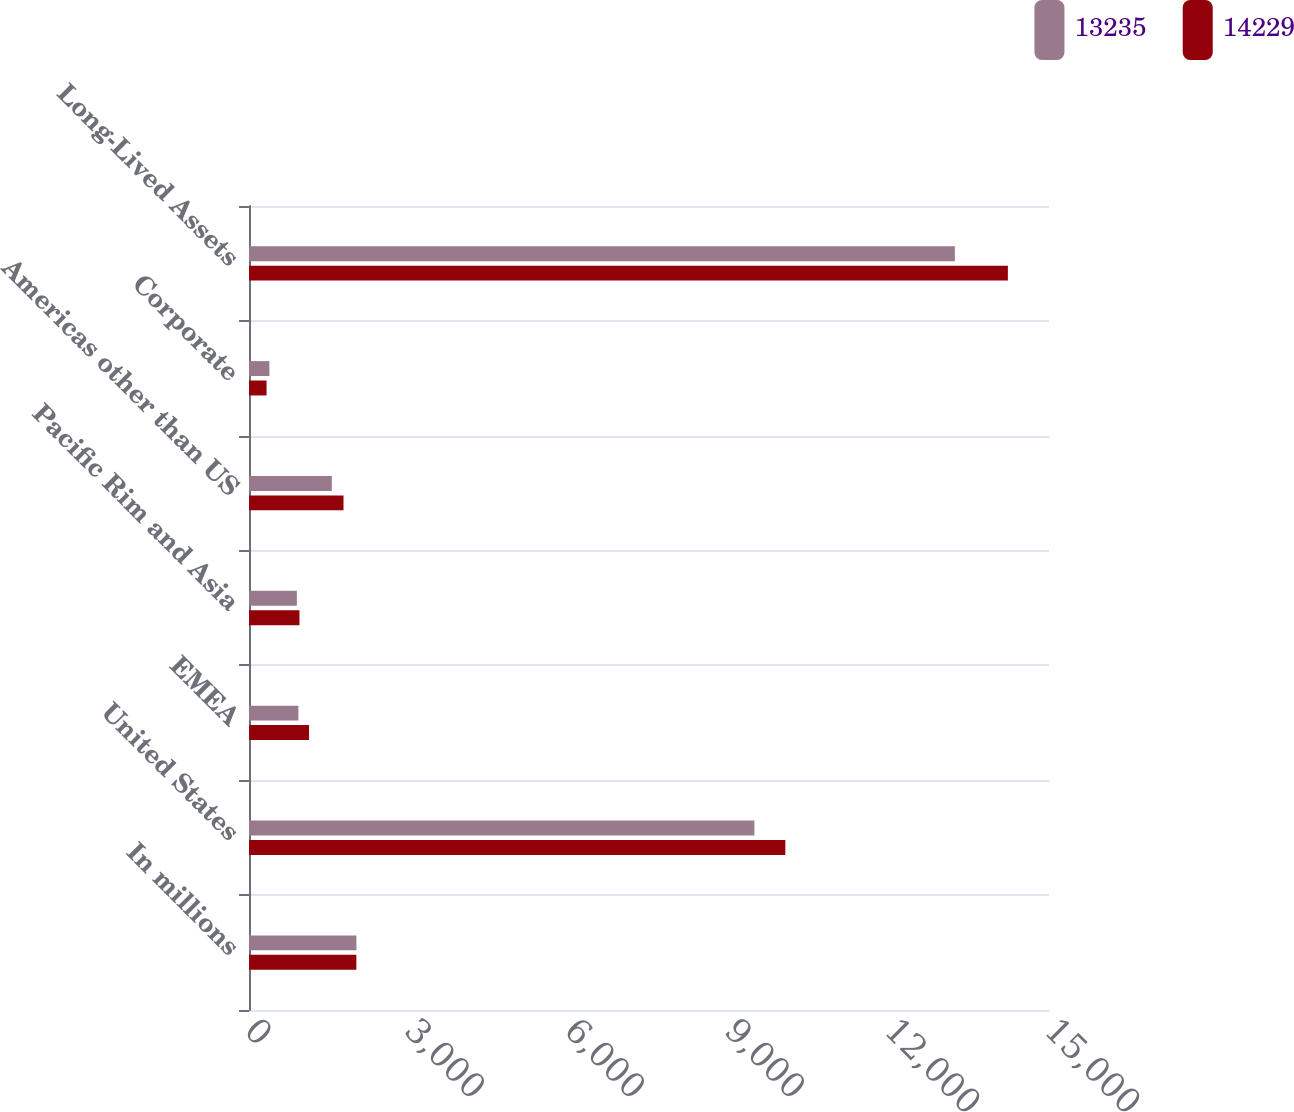Convert chart. <chart><loc_0><loc_0><loc_500><loc_500><stacked_bar_chart><ecel><fcel>In millions<fcel>United States<fcel>EMEA<fcel>Pacific Rim and Asia<fcel>Americas other than US<fcel>Corporate<fcel>Long-Lived Assets<nl><fcel>13235<fcel>2014<fcel>9476<fcel>926<fcel>897<fcel>1553<fcel>383<fcel>13235<nl><fcel>14229<fcel>2013<fcel>10056<fcel>1126<fcel>946<fcel>1772<fcel>329<fcel>14229<nl></chart> 